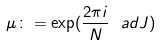<formula> <loc_0><loc_0><loc_500><loc_500>\mu \colon = \exp ( \frac { 2 \pi i } { N } \ a d J )</formula> 